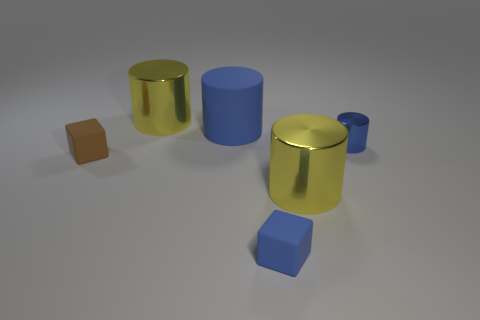What materials do the objects in the image appear to be made from? The objects in the image seem to have a metallic finish. The cylinders and cubes reflect light in a way that is typical of metal surfaces. 